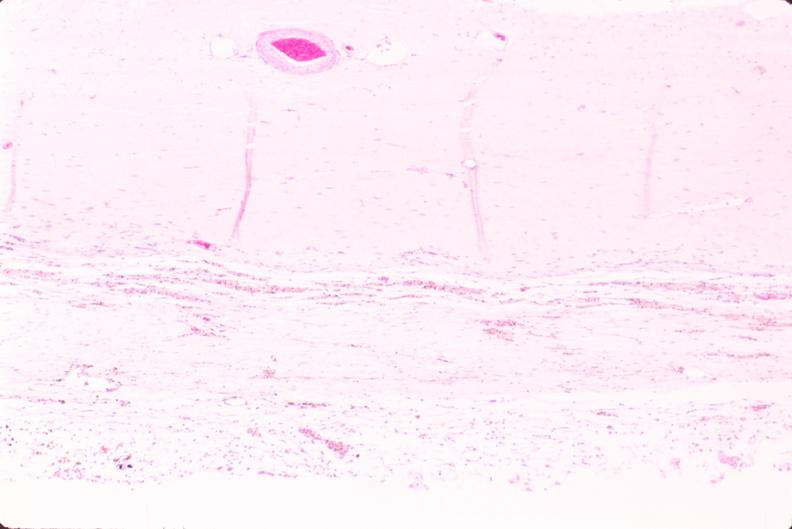s nervous present?
Answer the question using a single word or phrase. Yes 